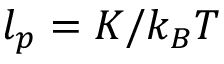<formula> <loc_0><loc_0><loc_500><loc_500>l _ { p } = K / k _ { B } T</formula> 